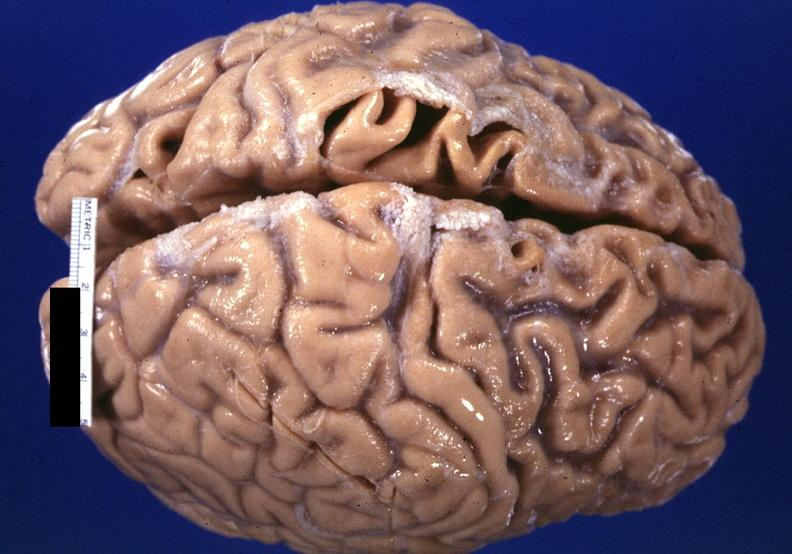does metastatic carcinoma show brain, frontal lobe atrophy, pick 's disease?
Answer the question using a single word or phrase. No 